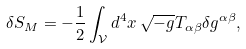<formula> <loc_0><loc_0><loc_500><loc_500>\delta S _ { M } = - \frac { 1 } { 2 } \int _ { \mathcal { V } } d ^ { 4 } x \, \sqrt { - g } T _ { \alpha \beta } \delta g ^ { \alpha \beta } ,</formula> 